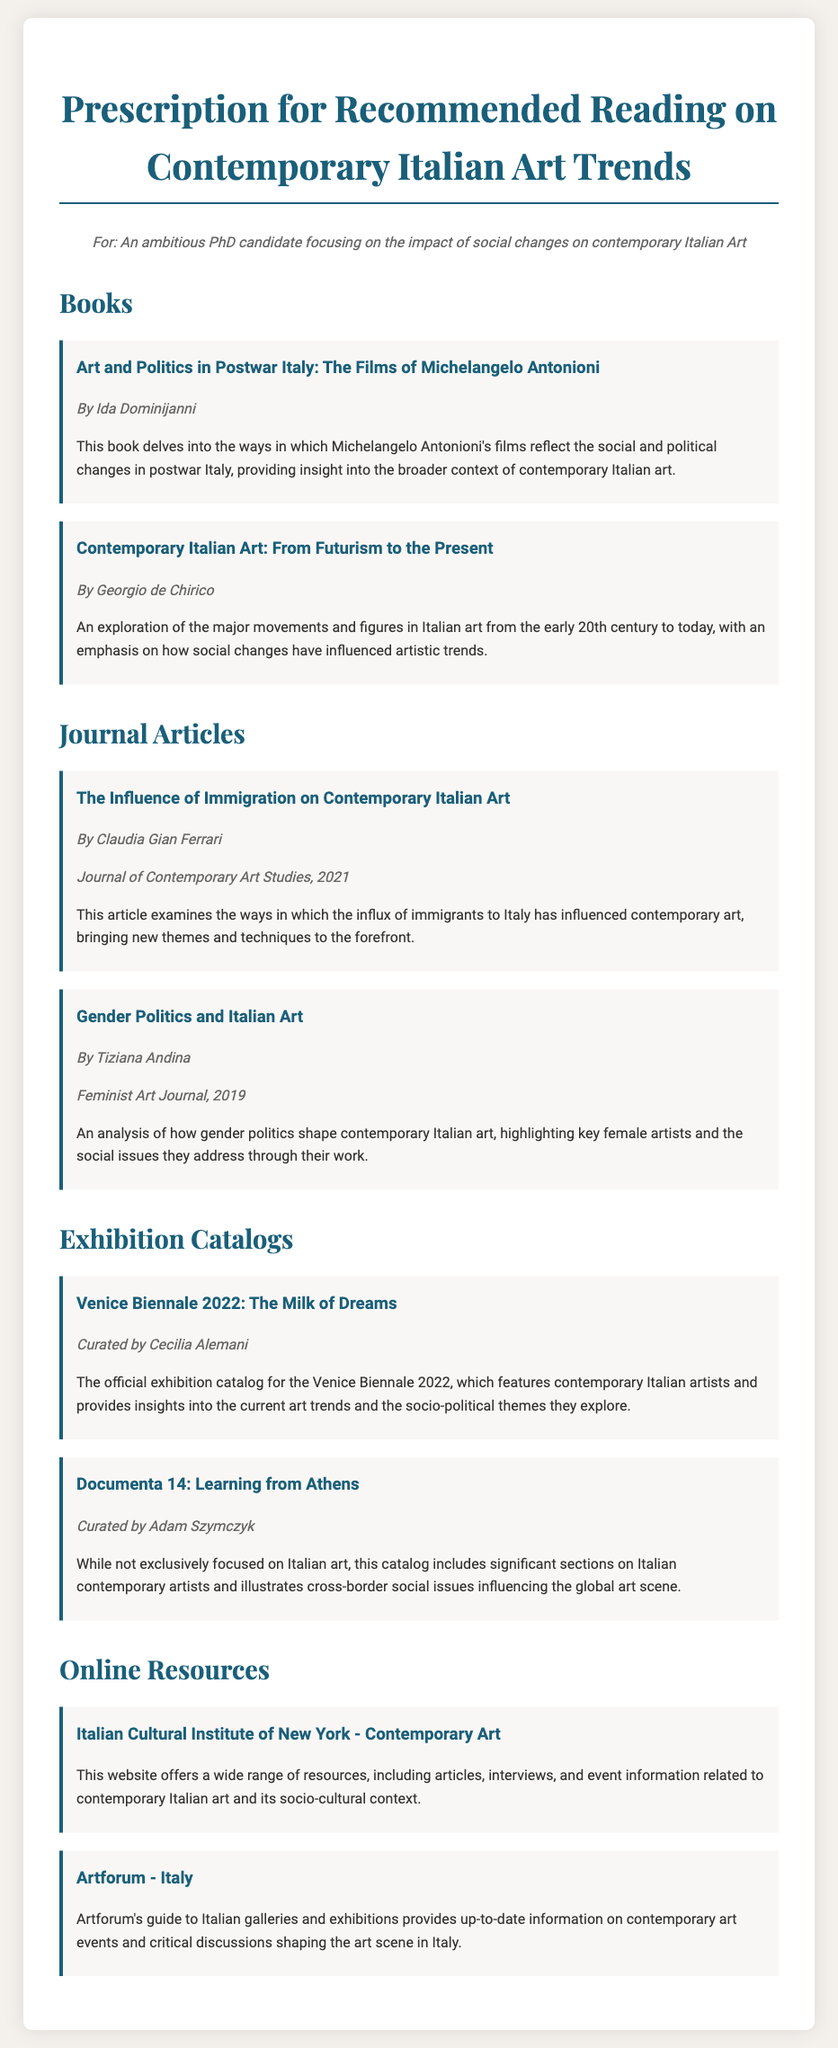What is the title of the first book listed? The title of the first book is mentioned in the section "Books" of the document.
Answer: Art and Politics in Postwar Italy: The Films of Michelangelo Antonioni Who is the author of the second book? The author of the second book can be found in the detail of the book listed under "Books".
Answer: Georgio de Chirico What journal published the article on immigration's influence? The journal is noted in the entry for the article on immigration, found in the section "Journal Articles".
Answer: Journal of Contemporary Art Studies What year was the article on gender politics published? The year of publication is specified in the entry for the article on gender politics in the "Journal Articles" section.
Answer: 2019 Who curated the Venice Biennale 2022 catalog? The curator's name is given in the section for "Exhibition Catalogs".
Answer: Cecilia Alemani How many online resources are provided? The number of online resources can be counted from the "Online Resources" section of the document.
Answer: 2 What kind of themes does the Venice Biennale 2022 explore? The themes are summarized in the description of the catalog in the "Exhibition Catalogs" section.
Answer: Socio-political themes Which institute offers resources related to contemporary Italian art? The response is found in the description of the online resources provided in the "Online Resources" section.
Answer: Italian Cultural Institute of New York 